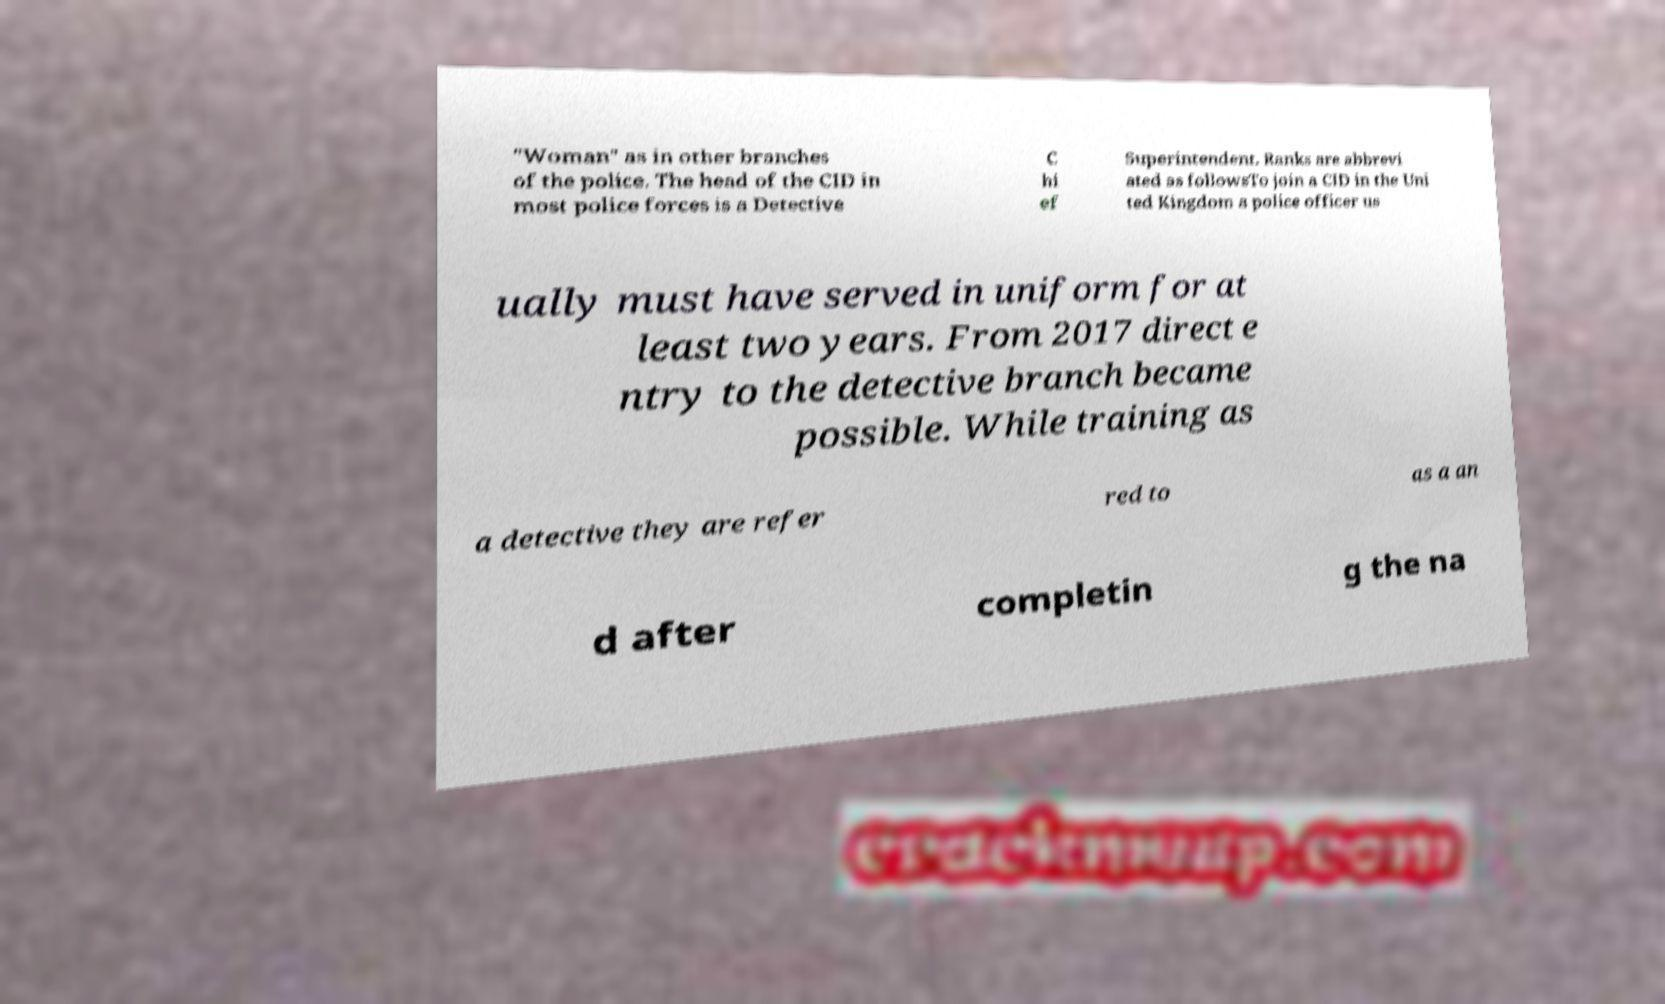Can you accurately transcribe the text from the provided image for me? "Woman" as in other branches of the police. The head of the CID in most police forces is a Detective C hi ef Superintendent. Ranks are abbrevi ated as followsTo join a CID in the Uni ted Kingdom a police officer us ually must have served in uniform for at least two years. From 2017 direct e ntry to the detective branch became possible. While training as a detective they are refer red to as a an d after completin g the na 